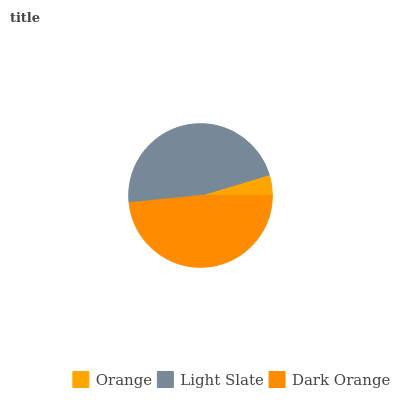Is Orange the minimum?
Answer yes or no. Yes. Is Dark Orange the maximum?
Answer yes or no. Yes. Is Light Slate the minimum?
Answer yes or no. No. Is Light Slate the maximum?
Answer yes or no. No. Is Light Slate greater than Orange?
Answer yes or no. Yes. Is Orange less than Light Slate?
Answer yes or no. Yes. Is Orange greater than Light Slate?
Answer yes or no. No. Is Light Slate less than Orange?
Answer yes or no. No. Is Light Slate the high median?
Answer yes or no. Yes. Is Light Slate the low median?
Answer yes or no. Yes. Is Orange the high median?
Answer yes or no. No. Is Dark Orange the low median?
Answer yes or no. No. 